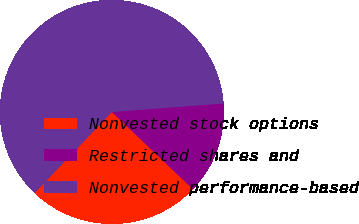Convert chart. <chart><loc_0><loc_0><loc_500><loc_500><pie_chart><fcel>Nonvested stock options<fcel>Restricted shares and<fcel>Nonvested performance-based<nl><fcel>25.0%<fcel>13.33%<fcel>61.67%<nl></chart> 